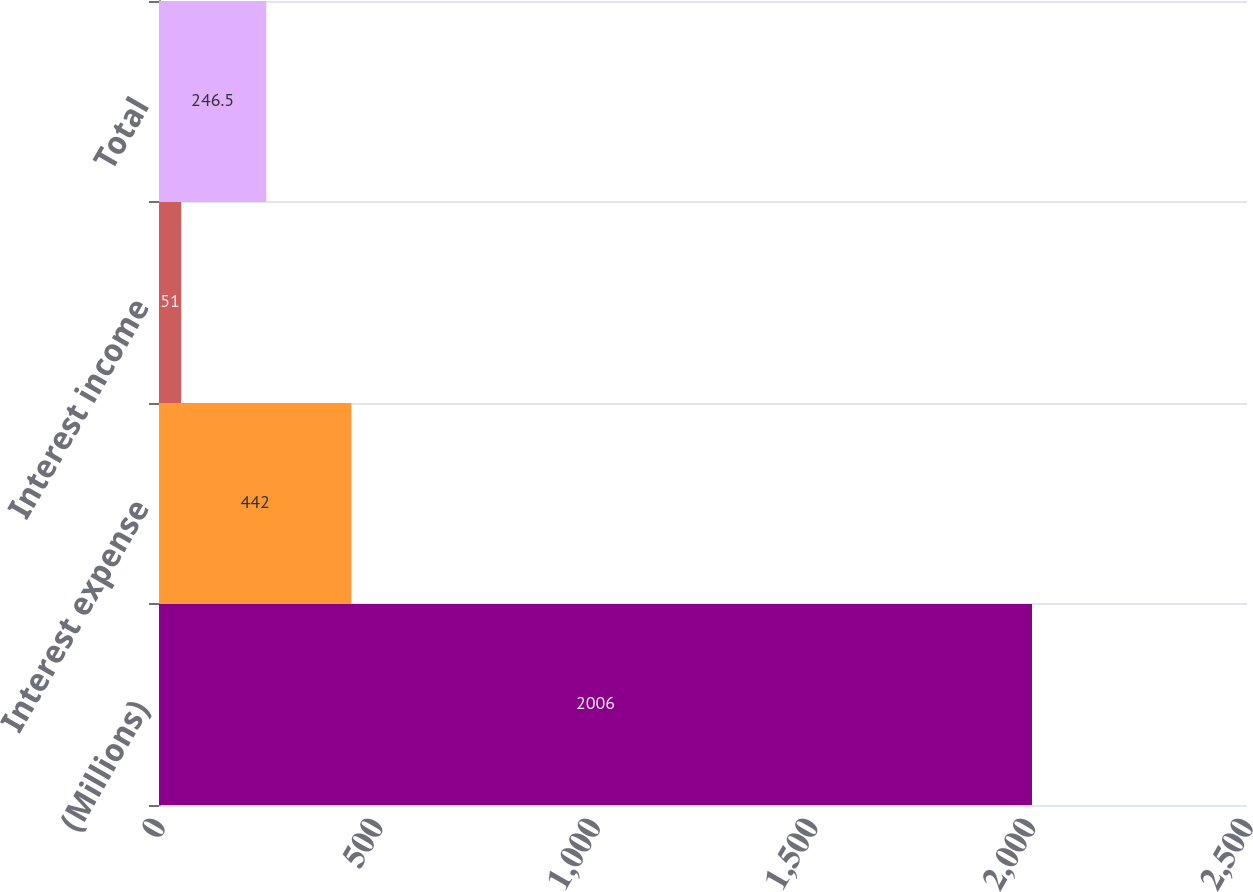Convert chart. <chart><loc_0><loc_0><loc_500><loc_500><bar_chart><fcel>(Millions)<fcel>Interest expense<fcel>Interest income<fcel>Total<nl><fcel>2006<fcel>442<fcel>51<fcel>246.5<nl></chart> 